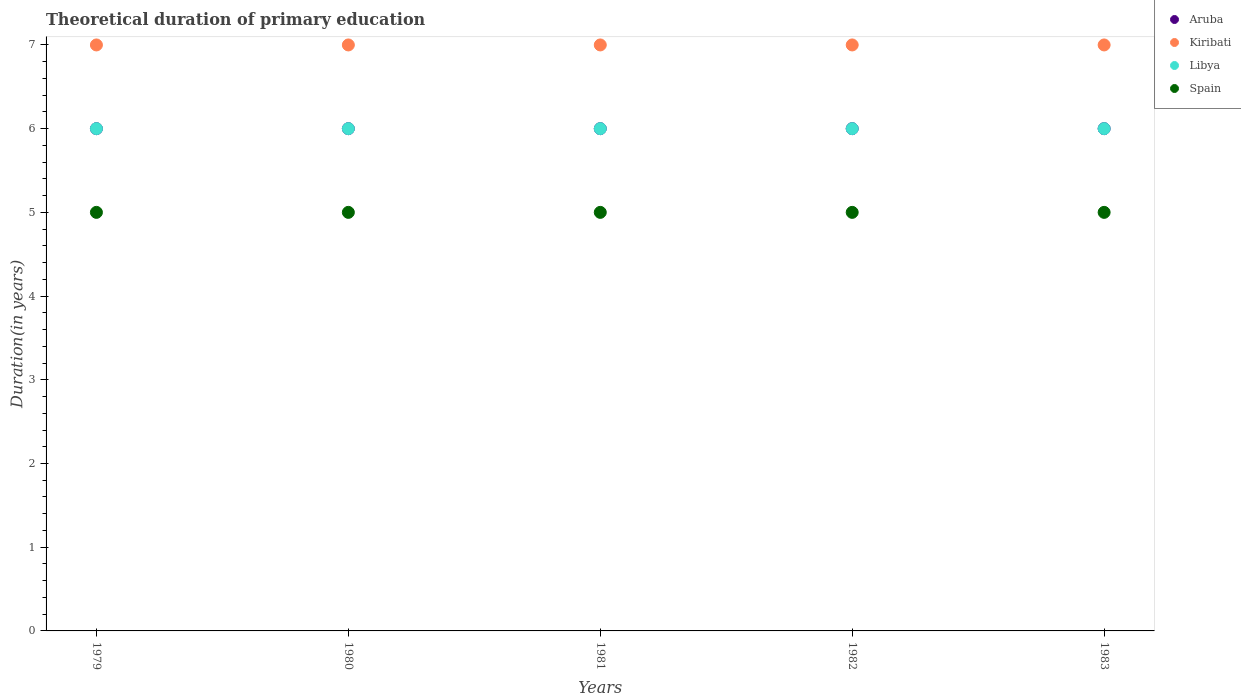How many different coloured dotlines are there?
Ensure brevity in your answer.  4. Is the number of dotlines equal to the number of legend labels?
Your answer should be very brief. Yes. Across all years, what is the maximum total theoretical duration of primary education in Aruba?
Give a very brief answer. 6. Across all years, what is the minimum total theoretical duration of primary education in Aruba?
Give a very brief answer. 6. In which year was the total theoretical duration of primary education in Kiribati maximum?
Keep it short and to the point. 1979. In which year was the total theoretical duration of primary education in Spain minimum?
Your answer should be compact. 1979. In the year 1980, what is the difference between the total theoretical duration of primary education in Libya and total theoretical duration of primary education in Aruba?
Provide a succinct answer. 0. Is the total theoretical duration of primary education in Aruba in 1980 less than that in 1983?
Keep it short and to the point. No. What is the difference between the highest and the second highest total theoretical duration of primary education in Kiribati?
Provide a succinct answer. 0. What is the difference between the highest and the lowest total theoretical duration of primary education in Aruba?
Your response must be concise. 0. Is it the case that in every year, the sum of the total theoretical duration of primary education in Spain and total theoretical duration of primary education in Aruba  is greater than the sum of total theoretical duration of primary education in Kiribati and total theoretical duration of primary education in Libya?
Offer a terse response. No. Does the total theoretical duration of primary education in Aruba monotonically increase over the years?
Your answer should be compact. No. What is the difference between two consecutive major ticks on the Y-axis?
Your answer should be very brief. 1. Does the graph contain any zero values?
Give a very brief answer. No. Where does the legend appear in the graph?
Your answer should be very brief. Top right. How many legend labels are there?
Give a very brief answer. 4. How are the legend labels stacked?
Your answer should be very brief. Vertical. What is the title of the graph?
Keep it short and to the point. Theoretical duration of primary education. Does "Uzbekistan" appear as one of the legend labels in the graph?
Offer a terse response. No. What is the label or title of the X-axis?
Your response must be concise. Years. What is the label or title of the Y-axis?
Offer a very short reply. Duration(in years). What is the Duration(in years) in Aruba in 1979?
Your answer should be compact. 6. What is the Duration(in years) of Kiribati in 1979?
Give a very brief answer. 7. What is the Duration(in years) of Libya in 1979?
Your answer should be compact. 6. What is the Duration(in years) in Spain in 1979?
Keep it short and to the point. 5. What is the Duration(in years) of Kiribati in 1980?
Your answer should be compact. 7. What is the Duration(in years) of Aruba in 1981?
Your response must be concise. 6. What is the Duration(in years) in Kiribati in 1981?
Ensure brevity in your answer.  7. What is the Duration(in years) of Libya in 1981?
Offer a very short reply. 6. What is the Duration(in years) of Aruba in 1982?
Provide a succinct answer. 6. What is the Duration(in years) of Libya in 1982?
Offer a terse response. 6. What is the Duration(in years) of Aruba in 1983?
Provide a short and direct response. 6. What is the Duration(in years) of Kiribati in 1983?
Offer a terse response. 7. What is the Duration(in years) in Libya in 1983?
Keep it short and to the point. 6. What is the Duration(in years) of Spain in 1983?
Your answer should be compact. 5. Across all years, what is the maximum Duration(in years) in Libya?
Give a very brief answer. 6. Across all years, what is the minimum Duration(in years) of Kiribati?
Provide a short and direct response. 7. Across all years, what is the minimum Duration(in years) in Spain?
Your answer should be very brief. 5. What is the total Duration(in years) in Kiribati in the graph?
Keep it short and to the point. 35. What is the difference between the Duration(in years) in Aruba in 1979 and that in 1980?
Give a very brief answer. 0. What is the difference between the Duration(in years) of Kiribati in 1979 and that in 1981?
Your answer should be very brief. 0. What is the difference between the Duration(in years) of Libya in 1979 and that in 1981?
Provide a short and direct response. 0. What is the difference between the Duration(in years) in Spain in 1979 and that in 1981?
Provide a short and direct response. 0. What is the difference between the Duration(in years) in Aruba in 1979 and that in 1982?
Offer a very short reply. 0. What is the difference between the Duration(in years) of Kiribati in 1979 and that in 1982?
Give a very brief answer. 0. What is the difference between the Duration(in years) in Libya in 1979 and that in 1982?
Your answer should be compact. 0. What is the difference between the Duration(in years) in Spain in 1979 and that in 1982?
Offer a terse response. 0. What is the difference between the Duration(in years) of Aruba in 1979 and that in 1983?
Keep it short and to the point. 0. What is the difference between the Duration(in years) in Kiribati in 1979 and that in 1983?
Ensure brevity in your answer.  0. What is the difference between the Duration(in years) in Aruba in 1980 and that in 1981?
Your answer should be compact. 0. What is the difference between the Duration(in years) in Kiribati in 1980 and that in 1981?
Make the answer very short. 0. What is the difference between the Duration(in years) of Spain in 1980 and that in 1981?
Ensure brevity in your answer.  0. What is the difference between the Duration(in years) in Aruba in 1980 and that in 1982?
Provide a succinct answer. 0. What is the difference between the Duration(in years) of Libya in 1980 and that in 1982?
Your response must be concise. 0. What is the difference between the Duration(in years) of Aruba in 1980 and that in 1983?
Offer a terse response. 0. What is the difference between the Duration(in years) of Kiribati in 1980 and that in 1983?
Provide a short and direct response. 0. What is the difference between the Duration(in years) of Libya in 1980 and that in 1983?
Give a very brief answer. 0. What is the difference between the Duration(in years) of Aruba in 1981 and that in 1982?
Your answer should be very brief. 0. What is the difference between the Duration(in years) of Kiribati in 1981 and that in 1982?
Your answer should be compact. 0. What is the difference between the Duration(in years) in Libya in 1981 and that in 1982?
Offer a terse response. 0. What is the difference between the Duration(in years) in Spain in 1981 and that in 1982?
Offer a very short reply. 0. What is the difference between the Duration(in years) of Aruba in 1981 and that in 1983?
Provide a succinct answer. 0. What is the difference between the Duration(in years) in Spain in 1981 and that in 1983?
Give a very brief answer. 0. What is the difference between the Duration(in years) of Aruba in 1982 and that in 1983?
Your answer should be very brief. 0. What is the difference between the Duration(in years) in Libya in 1982 and that in 1983?
Make the answer very short. 0. What is the difference between the Duration(in years) in Spain in 1982 and that in 1983?
Give a very brief answer. 0. What is the difference between the Duration(in years) in Aruba in 1979 and the Duration(in years) in Libya in 1980?
Keep it short and to the point. 0. What is the difference between the Duration(in years) of Libya in 1979 and the Duration(in years) of Spain in 1980?
Ensure brevity in your answer.  1. What is the difference between the Duration(in years) of Aruba in 1979 and the Duration(in years) of Libya in 1981?
Provide a succinct answer. 0. What is the difference between the Duration(in years) in Aruba in 1979 and the Duration(in years) in Libya in 1982?
Provide a short and direct response. 0. What is the difference between the Duration(in years) of Kiribati in 1979 and the Duration(in years) of Spain in 1982?
Give a very brief answer. 2. What is the difference between the Duration(in years) in Libya in 1979 and the Duration(in years) in Spain in 1982?
Your answer should be compact. 1. What is the difference between the Duration(in years) in Kiribati in 1979 and the Duration(in years) in Spain in 1983?
Give a very brief answer. 2. What is the difference between the Duration(in years) in Libya in 1979 and the Duration(in years) in Spain in 1983?
Keep it short and to the point. 1. What is the difference between the Duration(in years) in Aruba in 1980 and the Duration(in years) in Kiribati in 1981?
Give a very brief answer. -1. What is the difference between the Duration(in years) in Aruba in 1980 and the Duration(in years) in Libya in 1981?
Your answer should be compact. 0. What is the difference between the Duration(in years) of Kiribati in 1980 and the Duration(in years) of Libya in 1981?
Ensure brevity in your answer.  1. What is the difference between the Duration(in years) in Libya in 1980 and the Duration(in years) in Spain in 1981?
Provide a succinct answer. 1. What is the difference between the Duration(in years) in Aruba in 1980 and the Duration(in years) in Kiribati in 1982?
Provide a succinct answer. -1. What is the difference between the Duration(in years) of Aruba in 1980 and the Duration(in years) of Libya in 1982?
Offer a terse response. 0. What is the difference between the Duration(in years) in Aruba in 1980 and the Duration(in years) in Spain in 1982?
Your answer should be very brief. 1. What is the difference between the Duration(in years) in Kiribati in 1980 and the Duration(in years) in Libya in 1982?
Your answer should be very brief. 1. What is the difference between the Duration(in years) of Libya in 1980 and the Duration(in years) of Spain in 1982?
Offer a very short reply. 1. What is the difference between the Duration(in years) in Aruba in 1980 and the Duration(in years) in Libya in 1983?
Make the answer very short. 0. What is the difference between the Duration(in years) of Kiribati in 1980 and the Duration(in years) of Libya in 1983?
Keep it short and to the point. 1. What is the difference between the Duration(in years) in Kiribati in 1980 and the Duration(in years) in Spain in 1983?
Your answer should be compact. 2. What is the difference between the Duration(in years) of Aruba in 1981 and the Duration(in years) of Kiribati in 1982?
Make the answer very short. -1. What is the difference between the Duration(in years) of Aruba in 1981 and the Duration(in years) of Libya in 1982?
Offer a terse response. 0. What is the difference between the Duration(in years) in Aruba in 1981 and the Duration(in years) in Spain in 1982?
Give a very brief answer. 1. What is the difference between the Duration(in years) in Kiribati in 1981 and the Duration(in years) in Libya in 1982?
Your answer should be very brief. 1. What is the difference between the Duration(in years) in Kiribati in 1981 and the Duration(in years) in Spain in 1982?
Give a very brief answer. 2. What is the difference between the Duration(in years) in Libya in 1981 and the Duration(in years) in Spain in 1982?
Offer a terse response. 1. What is the difference between the Duration(in years) of Aruba in 1981 and the Duration(in years) of Libya in 1983?
Keep it short and to the point. 0. What is the difference between the Duration(in years) of Aruba in 1981 and the Duration(in years) of Spain in 1983?
Keep it short and to the point. 1. What is the difference between the Duration(in years) of Libya in 1981 and the Duration(in years) of Spain in 1983?
Keep it short and to the point. 1. What is the difference between the Duration(in years) of Aruba in 1982 and the Duration(in years) of Kiribati in 1983?
Provide a succinct answer. -1. What is the difference between the Duration(in years) of Aruba in 1982 and the Duration(in years) of Spain in 1983?
Make the answer very short. 1. What is the difference between the Duration(in years) of Kiribati in 1982 and the Duration(in years) of Spain in 1983?
Provide a short and direct response. 2. What is the average Duration(in years) of Kiribati per year?
Keep it short and to the point. 7. What is the average Duration(in years) of Libya per year?
Offer a terse response. 6. In the year 1979, what is the difference between the Duration(in years) in Aruba and Duration(in years) in Kiribati?
Offer a very short reply. -1. In the year 1979, what is the difference between the Duration(in years) in Kiribati and Duration(in years) in Libya?
Keep it short and to the point. 1. In the year 1980, what is the difference between the Duration(in years) in Aruba and Duration(in years) in Libya?
Ensure brevity in your answer.  0. In the year 1980, what is the difference between the Duration(in years) of Kiribati and Duration(in years) of Libya?
Keep it short and to the point. 1. In the year 1981, what is the difference between the Duration(in years) in Aruba and Duration(in years) in Spain?
Your answer should be compact. 1. In the year 1981, what is the difference between the Duration(in years) of Kiribati and Duration(in years) of Spain?
Your response must be concise. 2. In the year 1982, what is the difference between the Duration(in years) in Aruba and Duration(in years) in Spain?
Keep it short and to the point. 1. In the year 1982, what is the difference between the Duration(in years) of Kiribati and Duration(in years) of Libya?
Give a very brief answer. 1. In the year 1982, what is the difference between the Duration(in years) of Kiribati and Duration(in years) of Spain?
Ensure brevity in your answer.  2. In the year 1983, what is the difference between the Duration(in years) in Aruba and Duration(in years) in Kiribati?
Provide a short and direct response. -1. In the year 1983, what is the difference between the Duration(in years) of Aruba and Duration(in years) of Libya?
Ensure brevity in your answer.  0. In the year 1983, what is the difference between the Duration(in years) in Libya and Duration(in years) in Spain?
Provide a short and direct response. 1. What is the ratio of the Duration(in years) in Aruba in 1979 to that in 1980?
Ensure brevity in your answer.  1. What is the ratio of the Duration(in years) in Kiribati in 1979 to that in 1980?
Give a very brief answer. 1. What is the ratio of the Duration(in years) in Aruba in 1979 to that in 1981?
Provide a short and direct response. 1. What is the ratio of the Duration(in years) of Kiribati in 1979 to that in 1981?
Ensure brevity in your answer.  1. What is the ratio of the Duration(in years) in Spain in 1979 to that in 1981?
Your answer should be very brief. 1. What is the ratio of the Duration(in years) of Kiribati in 1979 to that in 1982?
Offer a very short reply. 1. What is the ratio of the Duration(in years) in Libya in 1979 to that in 1982?
Your response must be concise. 1. What is the ratio of the Duration(in years) of Spain in 1979 to that in 1982?
Give a very brief answer. 1. What is the ratio of the Duration(in years) of Kiribati in 1979 to that in 1983?
Provide a short and direct response. 1. What is the ratio of the Duration(in years) in Kiribati in 1980 to that in 1981?
Offer a very short reply. 1. What is the ratio of the Duration(in years) in Libya in 1980 to that in 1981?
Ensure brevity in your answer.  1. What is the ratio of the Duration(in years) in Aruba in 1980 to that in 1982?
Offer a very short reply. 1. What is the ratio of the Duration(in years) of Kiribati in 1980 to that in 1982?
Offer a very short reply. 1. What is the ratio of the Duration(in years) of Spain in 1980 to that in 1982?
Provide a succinct answer. 1. What is the ratio of the Duration(in years) of Libya in 1980 to that in 1983?
Offer a very short reply. 1. What is the ratio of the Duration(in years) of Spain in 1980 to that in 1983?
Your response must be concise. 1. What is the ratio of the Duration(in years) of Aruba in 1981 to that in 1983?
Your response must be concise. 1. What is the ratio of the Duration(in years) of Kiribati in 1981 to that in 1983?
Your response must be concise. 1. What is the ratio of the Duration(in years) in Libya in 1981 to that in 1983?
Provide a short and direct response. 1. What is the ratio of the Duration(in years) in Spain in 1981 to that in 1983?
Your answer should be very brief. 1. What is the ratio of the Duration(in years) in Aruba in 1982 to that in 1983?
Provide a short and direct response. 1. What is the ratio of the Duration(in years) of Libya in 1982 to that in 1983?
Make the answer very short. 1. What is the ratio of the Duration(in years) in Spain in 1982 to that in 1983?
Ensure brevity in your answer.  1. What is the difference between the highest and the second highest Duration(in years) in Aruba?
Ensure brevity in your answer.  0. What is the difference between the highest and the second highest Duration(in years) in Kiribati?
Your response must be concise. 0. What is the difference between the highest and the second highest Duration(in years) in Spain?
Keep it short and to the point. 0. What is the difference between the highest and the lowest Duration(in years) in Libya?
Offer a very short reply. 0. What is the difference between the highest and the lowest Duration(in years) in Spain?
Offer a terse response. 0. 